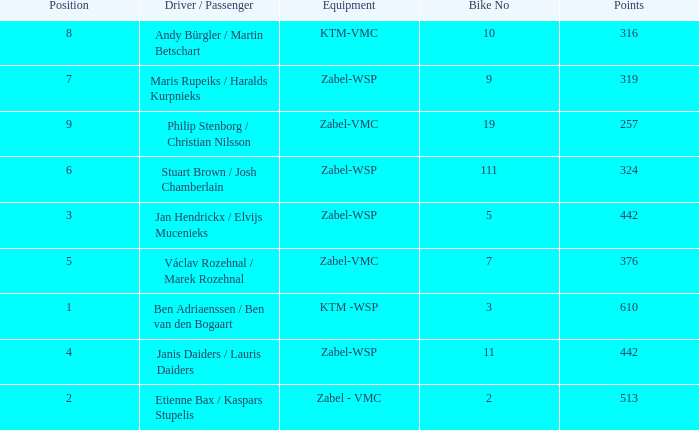What are the points for ktm-vmc equipment?  316.0. 